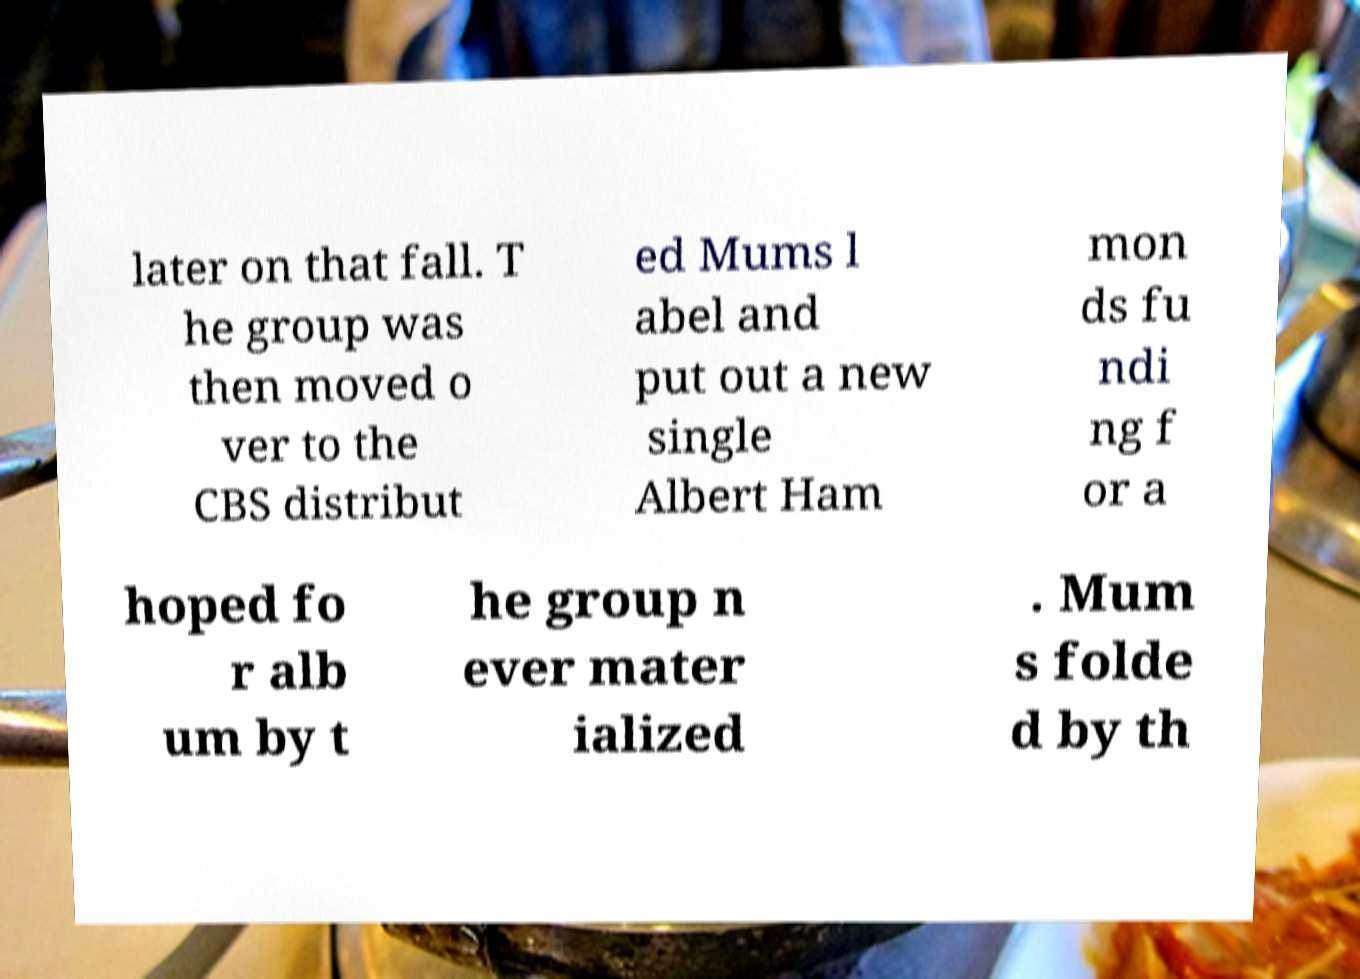There's text embedded in this image that I need extracted. Can you transcribe it verbatim? later on that fall. T he group was then moved o ver to the CBS distribut ed Mums l abel and put out a new single Albert Ham mon ds fu ndi ng f or a hoped fo r alb um by t he group n ever mater ialized . Mum s folde d by th 